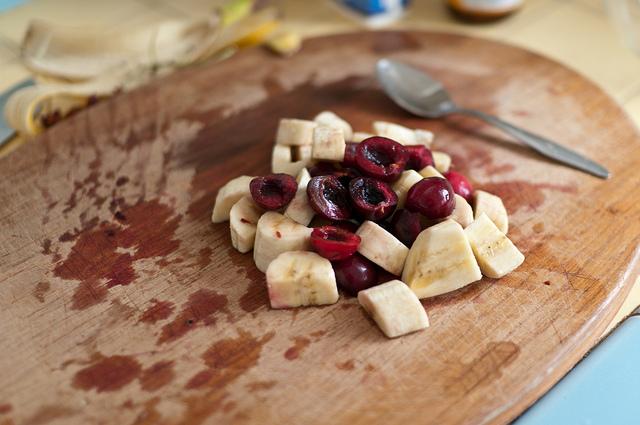Is there a spoon in the picture?
Keep it brief. Yes. Are the bananas chopped?
Write a very short answer. Yes. What is the shape of the cutting board?
Keep it brief. Oval. 